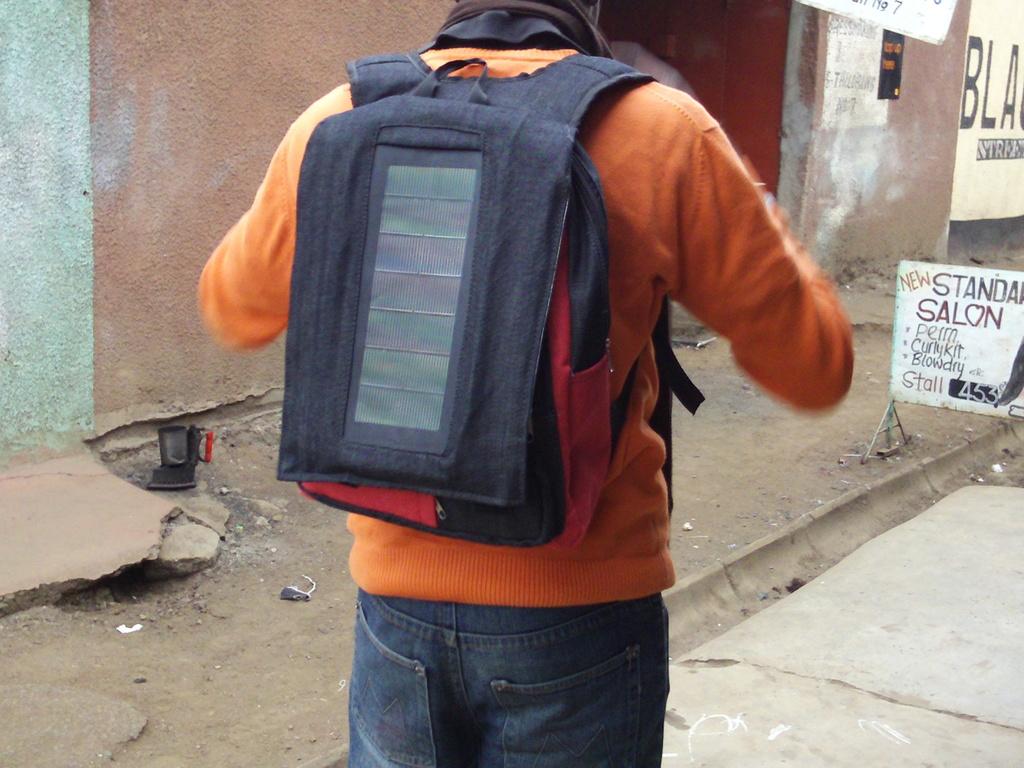What is the top word on the sign?
Your response must be concise. New. What are the large words on the white sign?
Your response must be concise. Standard salon. 